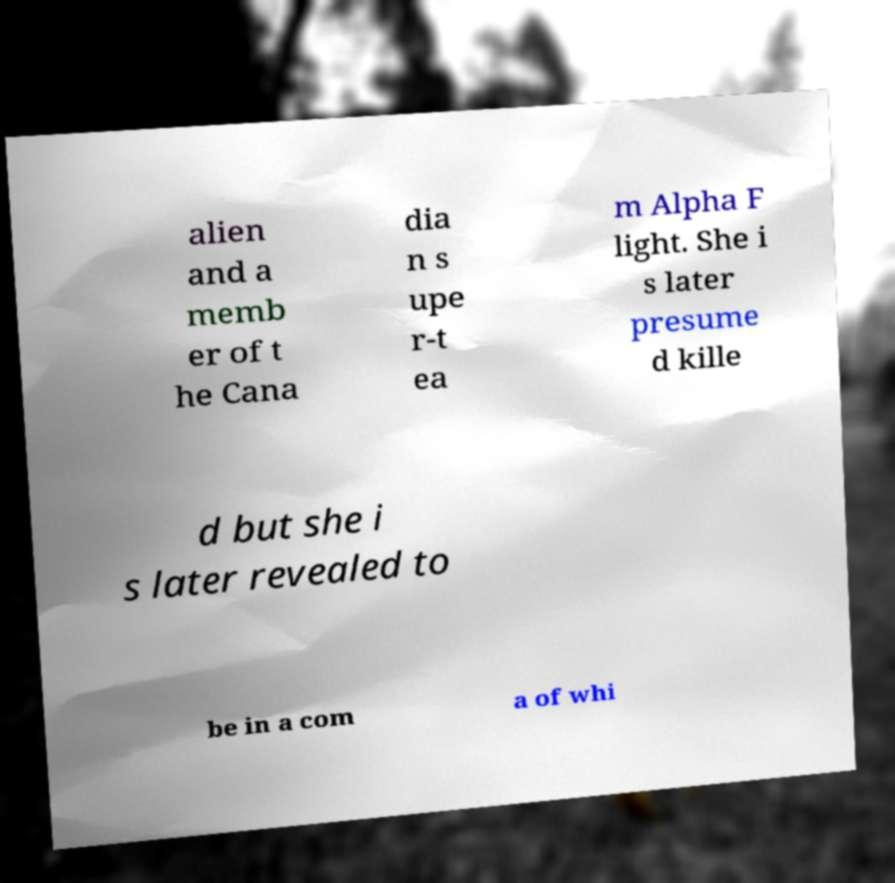Please read and relay the text visible in this image. What does it say? alien and a memb er of t he Cana dia n s upe r-t ea m Alpha F light. She i s later presume d kille d but she i s later revealed to be in a com a of whi 